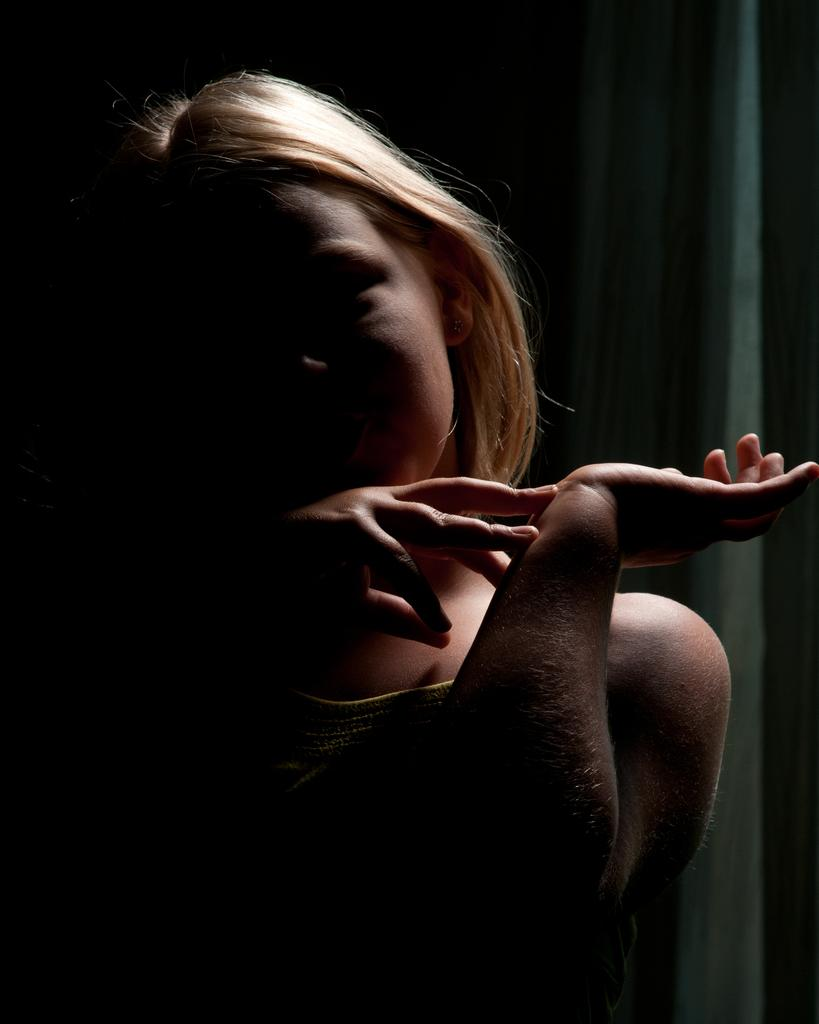What can be observed about the background of the image? The background of the image is dark and blurred. Can you describe the main subject of the image? There is a person in the picture. What type of pancake is being served to the person in the image? There is no pancake present in the image; it only features a person with a dark and blurred background. 